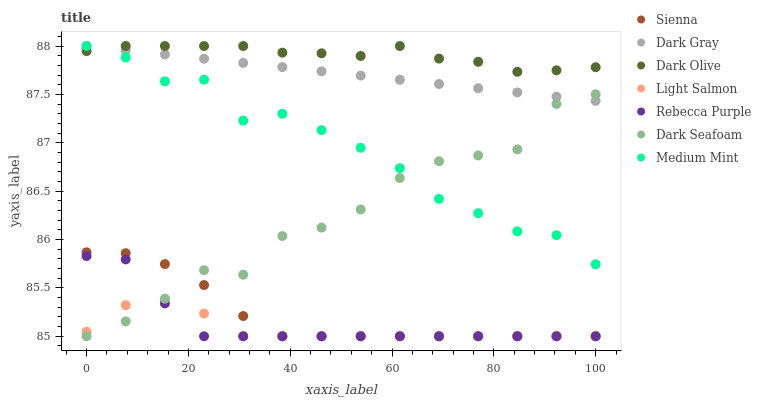Does Light Salmon have the minimum area under the curve?
Answer yes or no. Yes. Does Dark Olive have the maximum area under the curve?
Answer yes or no. Yes. Does Dark Gray have the minimum area under the curve?
Answer yes or no. No. Does Dark Gray have the maximum area under the curve?
Answer yes or no. No. Is Dark Gray the smoothest?
Answer yes or no. Yes. Is Dark Seafoam the roughest?
Answer yes or no. Yes. Is Light Salmon the smoothest?
Answer yes or no. No. Is Light Salmon the roughest?
Answer yes or no. No. Does Light Salmon have the lowest value?
Answer yes or no. Yes. Does Dark Gray have the lowest value?
Answer yes or no. No. Does Dark Olive have the highest value?
Answer yes or no. Yes. Does Light Salmon have the highest value?
Answer yes or no. No. Is Dark Seafoam less than Dark Olive?
Answer yes or no. Yes. Is Medium Mint greater than Rebecca Purple?
Answer yes or no. Yes. Does Rebecca Purple intersect Light Salmon?
Answer yes or no. Yes. Is Rebecca Purple less than Light Salmon?
Answer yes or no. No. Is Rebecca Purple greater than Light Salmon?
Answer yes or no. No. Does Dark Seafoam intersect Dark Olive?
Answer yes or no. No. 